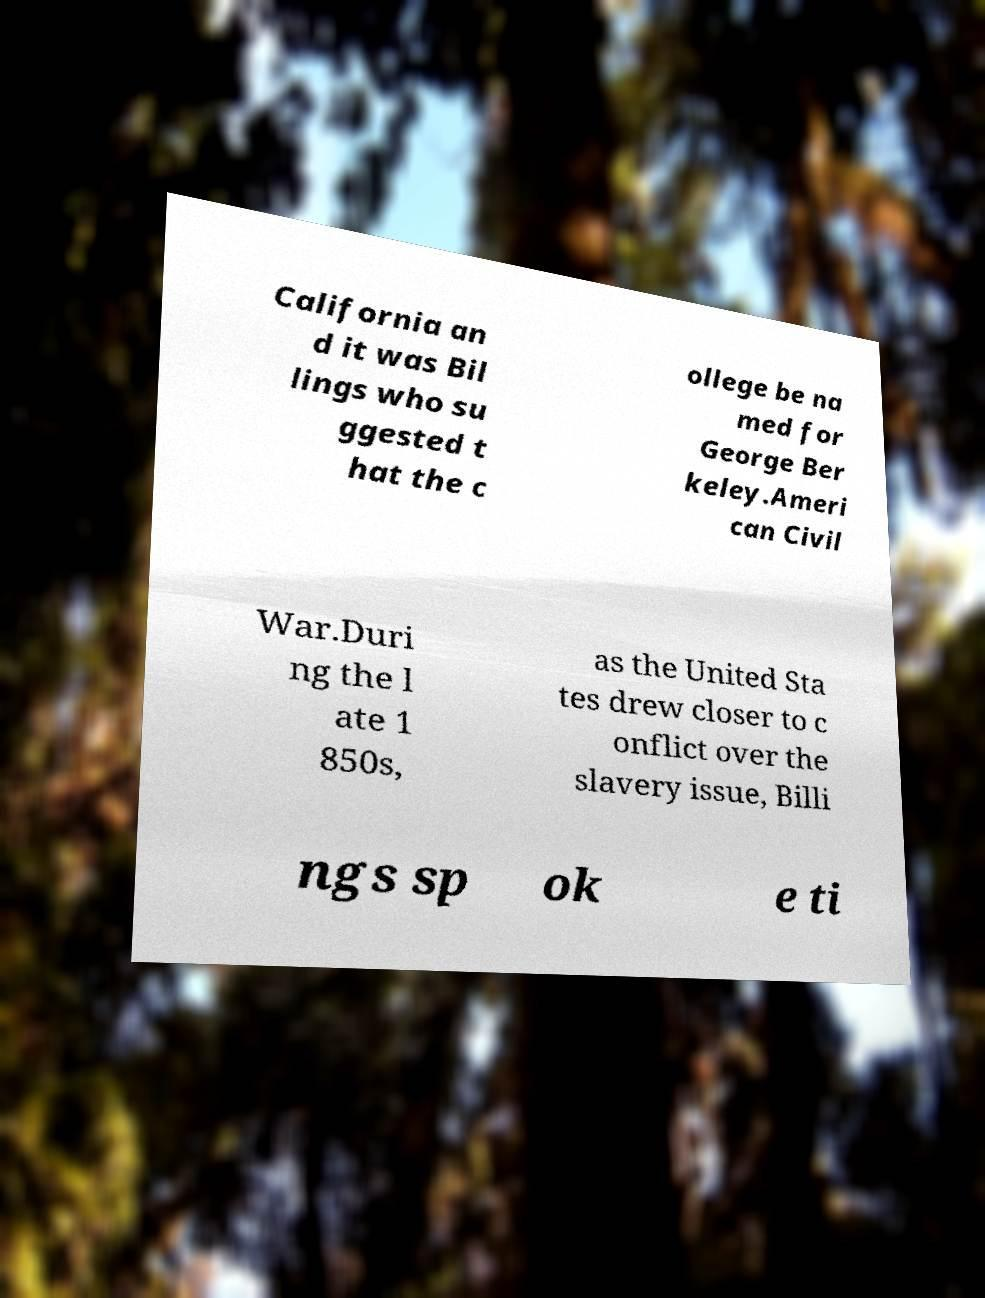What messages or text are displayed in this image? I need them in a readable, typed format. California an d it was Bil lings who su ggested t hat the c ollege be na med for George Ber keley.Ameri can Civil War.Duri ng the l ate 1 850s, as the United Sta tes drew closer to c onflict over the slavery issue, Billi ngs sp ok e ti 